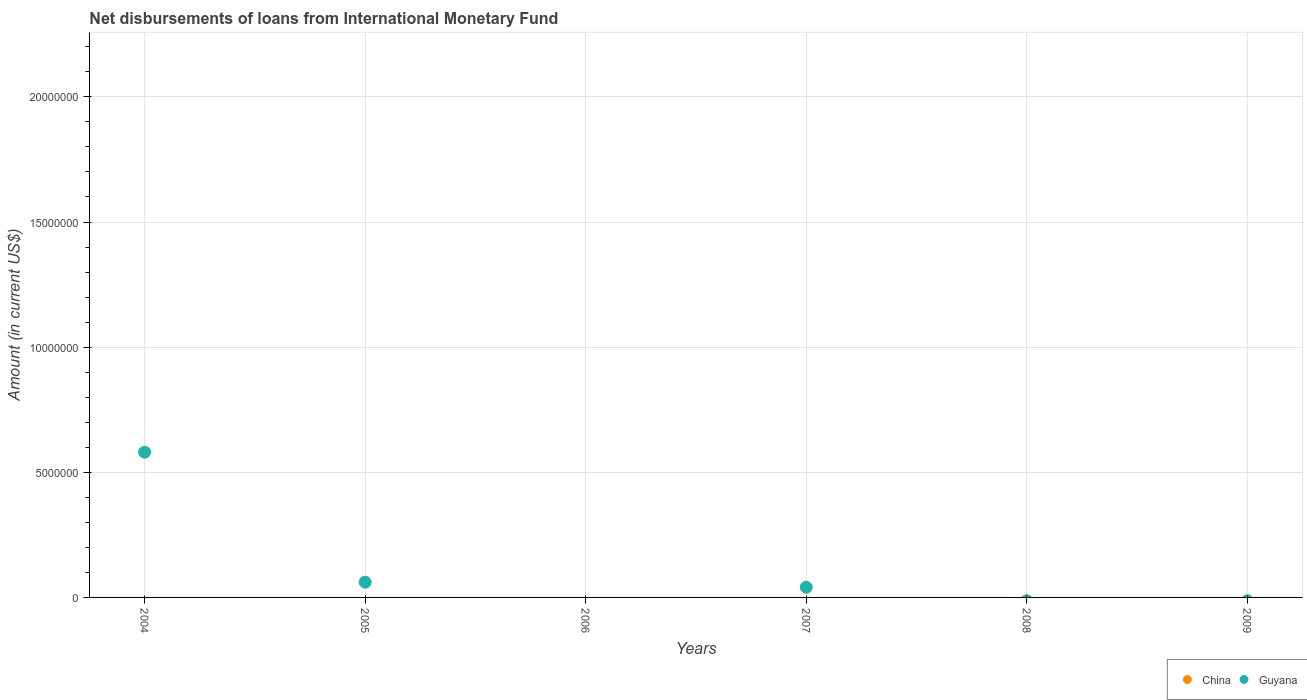How many different coloured dotlines are there?
Your answer should be very brief. 1. Is the number of dotlines equal to the number of legend labels?
Your response must be concise. No. What is the amount of loans disbursed in Guyana in 2005?
Offer a terse response. 6.09e+05. Across all years, what is the maximum amount of loans disbursed in Guyana?
Give a very brief answer. 5.80e+06. In which year was the amount of loans disbursed in Guyana maximum?
Offer a very short reply. 2004. What is the total amount of loans disbursed in Guyana in the graph?
Offer a terse response. 6.82e+06. What is the difference between the amount of loans disbursed in Guyana in 2004 and that in 2007?
Make the answer very short. 5.40e+06. What is the average amount of loans disbursed in Guyana per year?
Offer a very short reply. 1.14e+06. What is the difference between the highest and the second highest amount of loans disbursed in Guyana?
Keep it short and to the point. 5.20e+06. What is the difference between the highest and the lowest amount of loans disbursed in Guyana?
Provide a short and direct response. 5.80e+06. In how many years, is the amount of loans disbursed in Guyana greater than the average amount of loans disbursed in Guyana taken over all years?
Provide a short and direct response. 1. Is the sum of the amount of loans disbursed in Guyana in 2004 and 2007 greater than the maximum amount of loans disbursed in China across all years?
Keep it short and to the point. Yes. Does the amount of loans disbursed in China monotonically increase over the years?
Your response must be concise. No. How many dotlines are there?
Your response must be concise. 1. How many years are there in the graph?
Provide a succinct answer. 6. What is the difference between two consecutive major ticks on the Y-axis?
Provide a short and direct response. 5.00e+06. Does the graph contain grids?
Your answer should be very brief. Yes. What is the title of the graph?
Make the answer very short. Net disbursements of loans from International Monetary Fund. Does "Low income" appear as one of the legend labels in the graph?
Provide a succinct answer. No. What is the label or title of the X-axis?
Your response must be concise. Years. What is the label or title of the Y-axis?
Your answer should be very brief. Amount (in current US$). What is the Amount (in current US$) in China in 2004?
Offer a terse response. 0. What is the Amount (in current US$) in Guyana in 2004?
Give a very brief answer. 5.80e+06. What is the Amount (in current US$) in Guyana in 2005?
Your answer should be very brief. 6.09e+05. What is the Amount (in current US$) of China in 2006?
Provide a short and direct response. 0. What is the Amount (in current US$) in Guyana in 2006?
Your response must be concise. 0. What is the Amount (in current US$) in China in 2007?
Offer a terse response. 0. What is the Amount (in current US$) in Guyana in 2007?
Make the answer very short. 4.06e+05. What is the Amount (in current US$) of Guyana in 2008?
Make the answer very short. 0. What is the Amount (in current US$) in China in 2009?
Your answer should be compact. 0. What is the Amount (in current US$) in Guyana in 2009?
Keep it short and to the point. 0. Across all years, what is the maximum Amount (in current US$) of Guyana?
Your answer should be compact. 5.80e+06. Across all years, what is the minimum Amount (in current US$) of Guyana?
Provide a short and direct response. 0. What is the total Amount (in current US$) of Guyana in the graph?
Provide a succinct answer. 6.82e+06. What is the difference between the Amount (in current US$) of Guyana in 2004 and that in 2005?
Make the answer very short. 5.20e+06. What is the difference between the Amount (in current US$) in Guyana in 2004 and that in 2007?
Your answer should be compact. 5.40e+06. What is the difference between the Amount (in current US$) in Guyana in 2005 and that in 2007?
Your response must be concise. 2.03e+05. What is the average Amount (in current US$) in Guyana per year?
Make the answer very short. 1.14e+06. What is the ratio of the Amount (in current US$) of Guyana in 2004 to that in 2005?
Provide a short and direct response. 9.53. What is the ratio of the Amount (in current US$) of Guyana in 2004 to that in 2007?
Your answer should be very brief. 14.3. What is the ratio of the Amount (in current US$) in Guyana in 2005 to that in 2007?
Offer a very short reply. 1.5. What is the difference between the highest and the second highest Amount (in current US$) in Guyana?
Keep it short and to the point. 5.20e+06. What is the difference between the highest and the lowest Amount (in current US$) in Guyana?
Provide a short and direct response. 5.80e+06. 